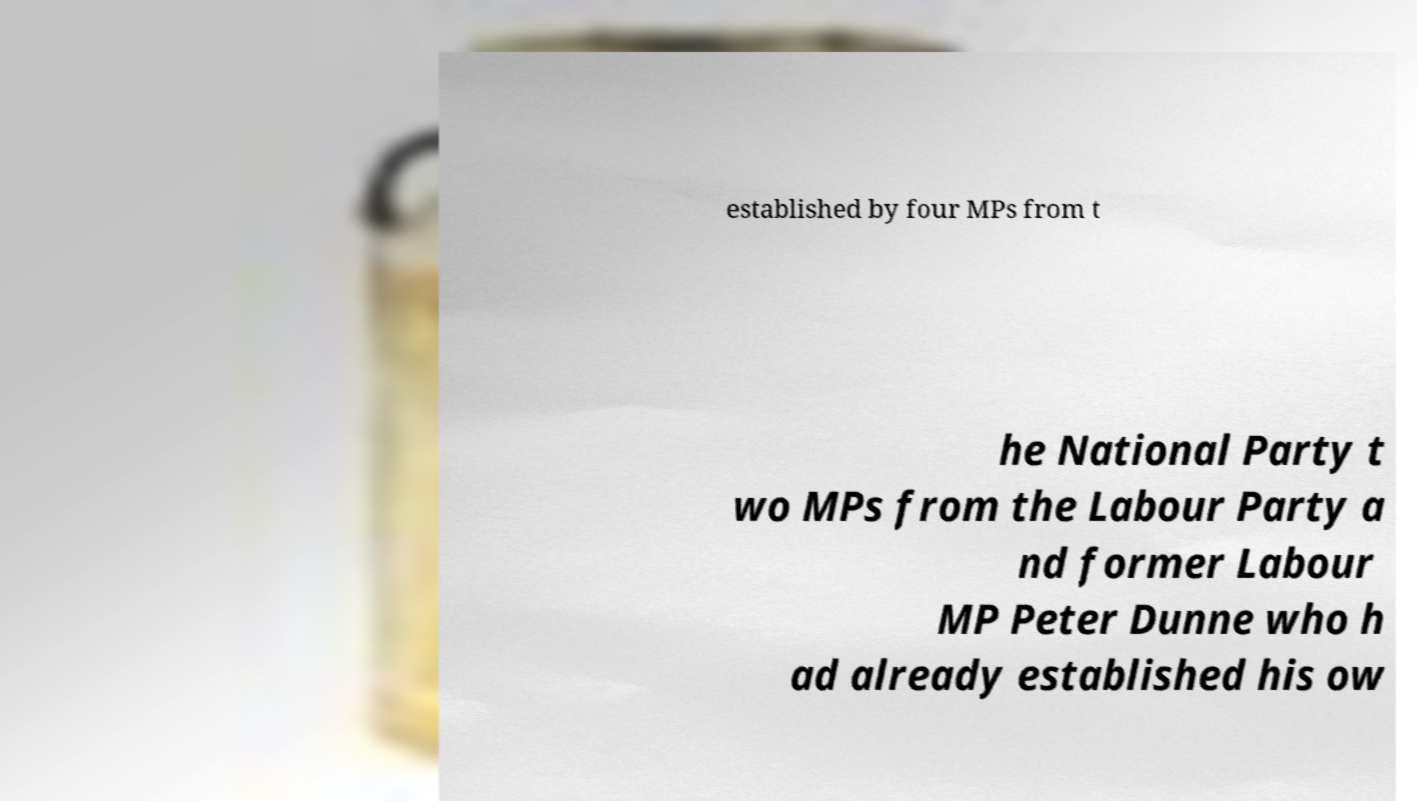Can you accurately transcribe the text from the provided image for me? established by four MPs from t he National Party t wo MPs from the Labour Party a nd former Labour MP Peter Dunne who h ad already established his ow 